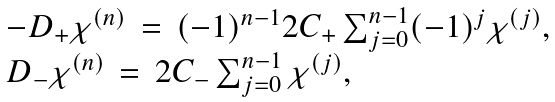Convert formula to latex. <formula><loc_0><loc_0><loc_500><loc_500>\begin{array} { l l } - D _ { + } \chi ^ { ( n ) } \, = \, ( - 1 ) ^ { n - 1 } 2 C _ { + } \sum _ { j = 0 } ^ { n - 1 } ( - 1 ) ^ { j } \chi ^ { ( j ) } , \\ D _ { - } \chi ^ { ( n ) } \, = \, 2 C _ { - } \sum _ { j = 0 } ^ { n - 1 } \chi ^ { ( j ) } , \end{array}</formula> 